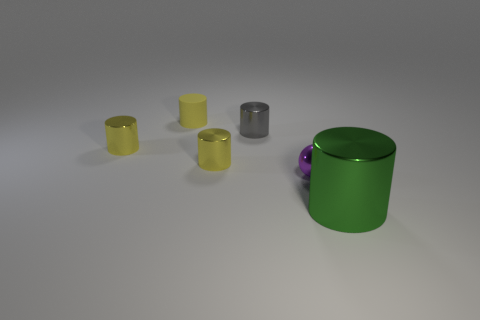Subtract all purple spheres. How many yellow cylinders are left? 3 Subtract all big green metallic cylinders. How many cylinders are left? 4 Subtract all green cylinders. How many cylinders are left? 4 Subtract all cyan cylinders. Subtract all blue cubes. How many cylinders are left? 5 Add 2 rubber objects. How many objects exist? 8 Subtract all cylinders. How many objects are left? 1 Add 5 small cylinders. How many small cylinders are left? 9 Add 3 tiny metallic things. How many tiny metallic things exist? 7 Subtract 0 brown cylinders. How many objects are left? 6 Subtract all tiny shiny spheres. Subtract all large blue spheres. How many objects are left? 5 